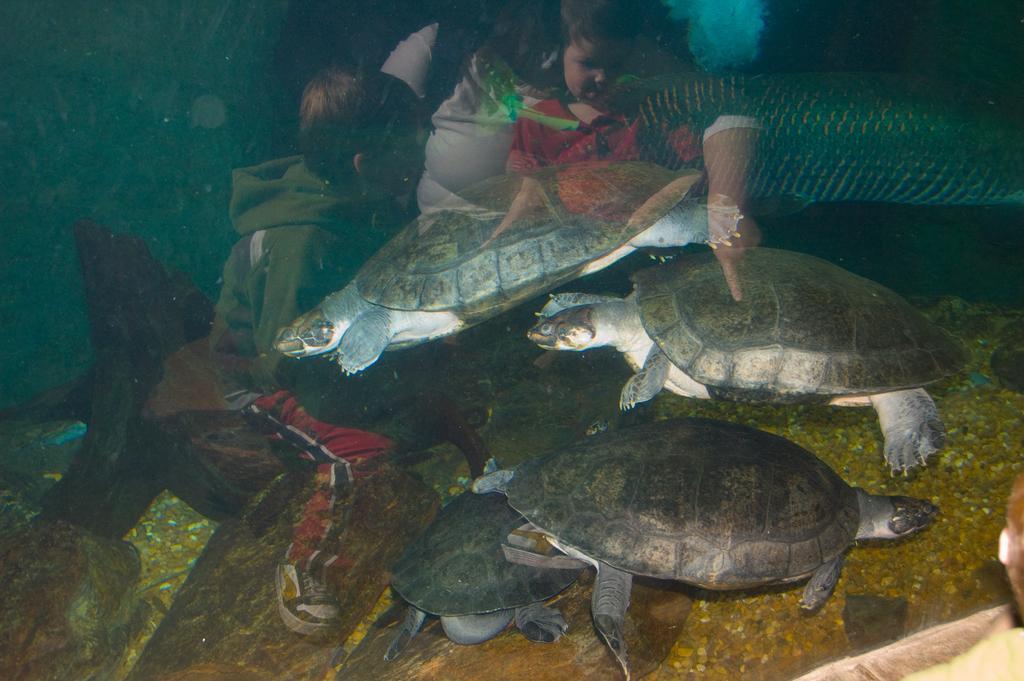Could you give a brief overview of what you see in this image? In this image I can see few turtles in the water. I can also see few children and one more person in the centre of this image. 